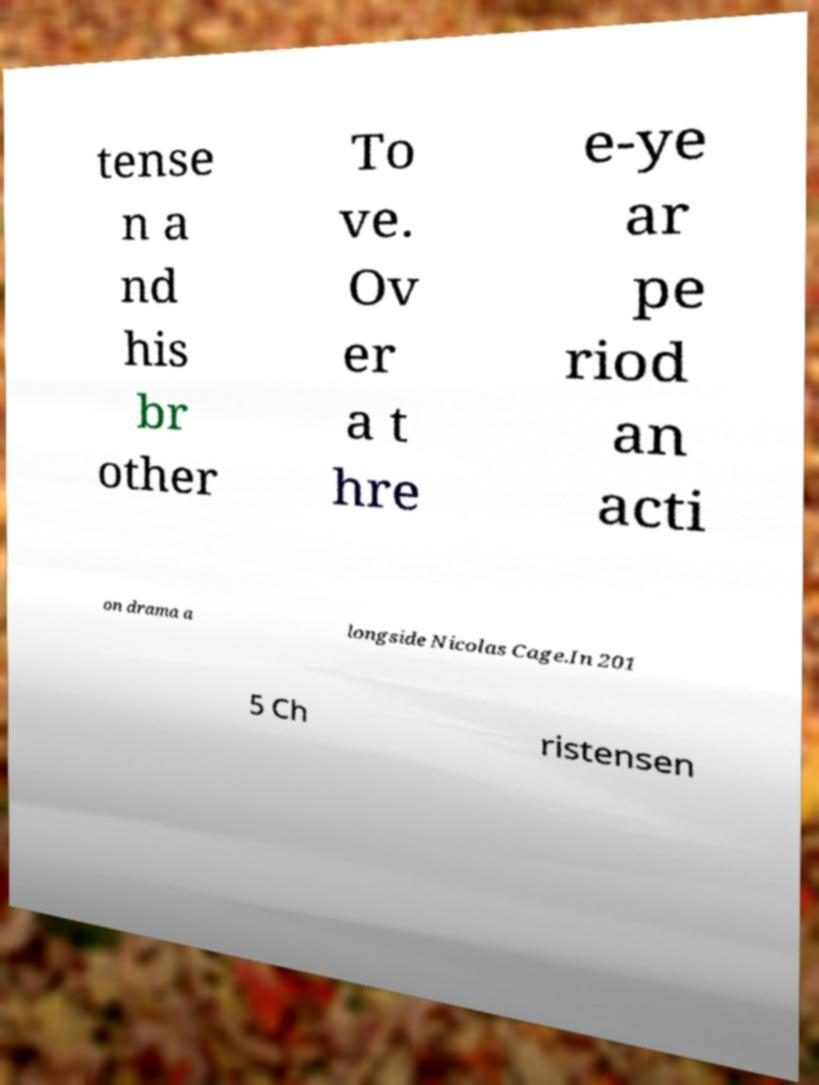For documentation purposes, I need the text within this image transcribed. Could you provide that? tense n a nd his br other To ve. Ov er a t hre e-ye ar pe riod an acti on drama a longside Nicolas Cage.In 201 5 Ch ristensen 